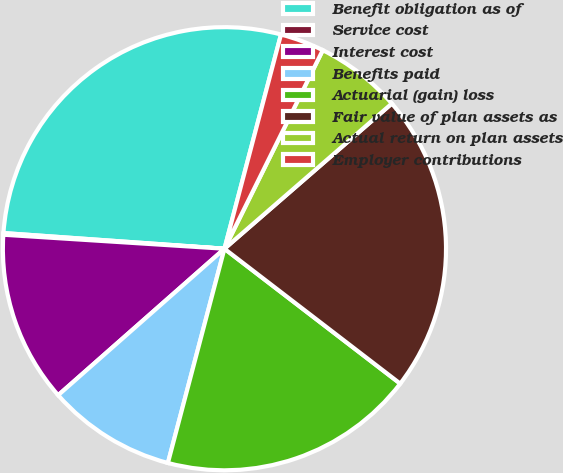<chart> <loc_0><loc_0><loc_500><loc_500><pie_chart><fcel>Benefit obligation as of<fcel>Service cost<fcel>Interest cost<fcel>Benefits paid<fcel>Actuarial (gain) loss<fcel>Fair value of plan assets as<fcel>Actual return on plan assets<fcel>Employer contributions<nl><fcel>27.98%<fcel>0.12%<fcel>12.5%<fcel>9.4%<fcel>18.69%<fcel>21.79%<fcel>6.31%<fcel>3.21%<nl></chart> 